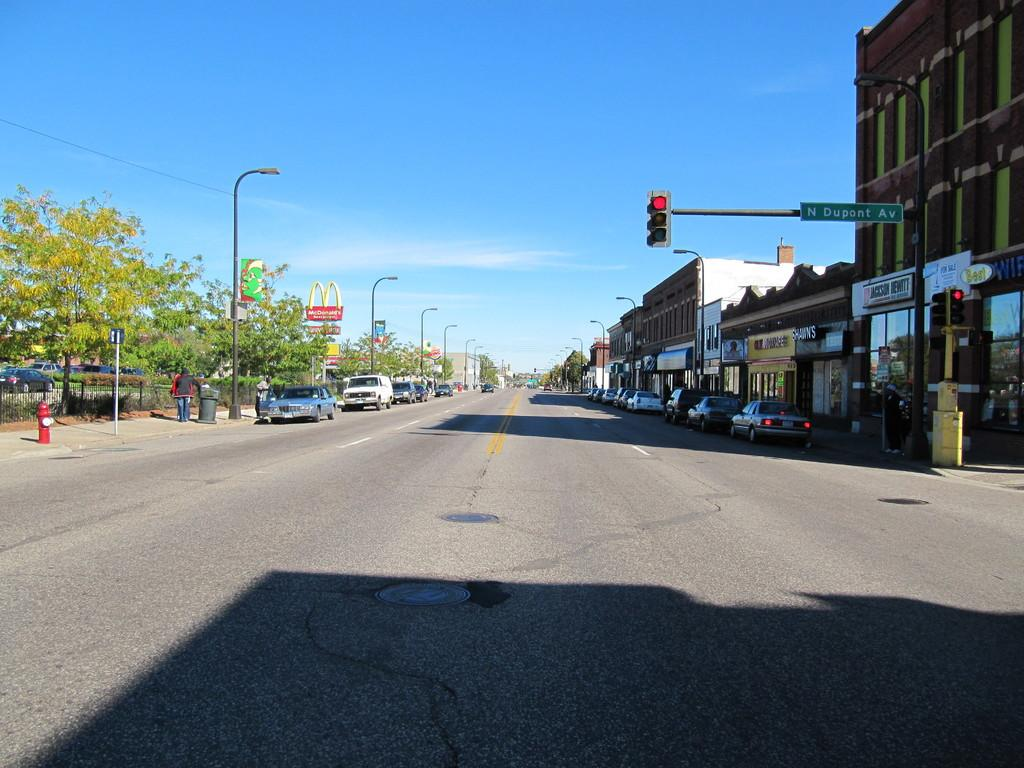<image>
Present a compact description of the photo's key features. A stop light at N Dupont Av with a McDonalds in site 